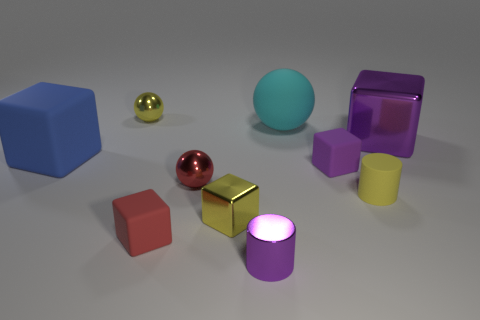Subtract all gray cylinders. How many purple blocks are left? 2 Subtract all purple blocks. How many blocks are left? 3 Subtract all red cubes. How many cubes are left? 4 Subtract 2 blocks. How many blocks are left? 3 Subtract all cylinders. How many objects are left? 8 Subtract all blue cubes. Subtract all gray cylinders. How many cubes are left? 4 Subtract all tiny red cubes. Subtract all cyan balls. How many objects are left? 8 Add 5 yellow balls. How many yellow balls are left? 6 Add 3 big blue matte objects. How many big blue matte objects exist? 4 Subtract 0 green balls. How many objects are left? 10 